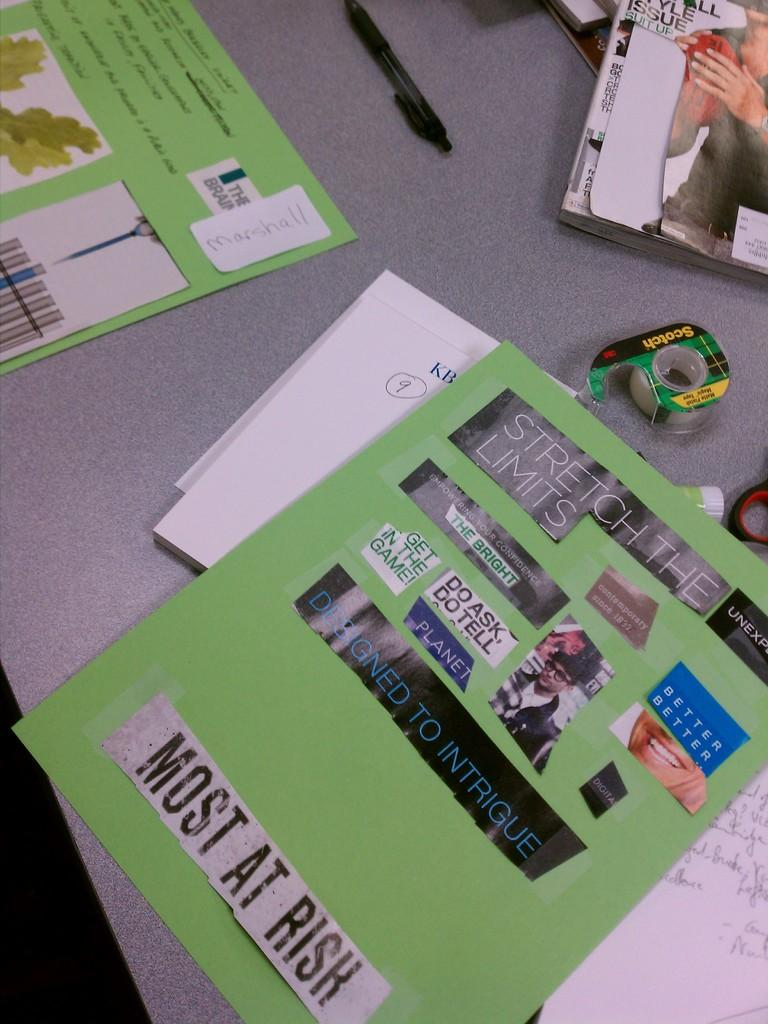<image>
Render a clear and concise summary of the photo. a sheet of paper with random words and most at rish on bottom 